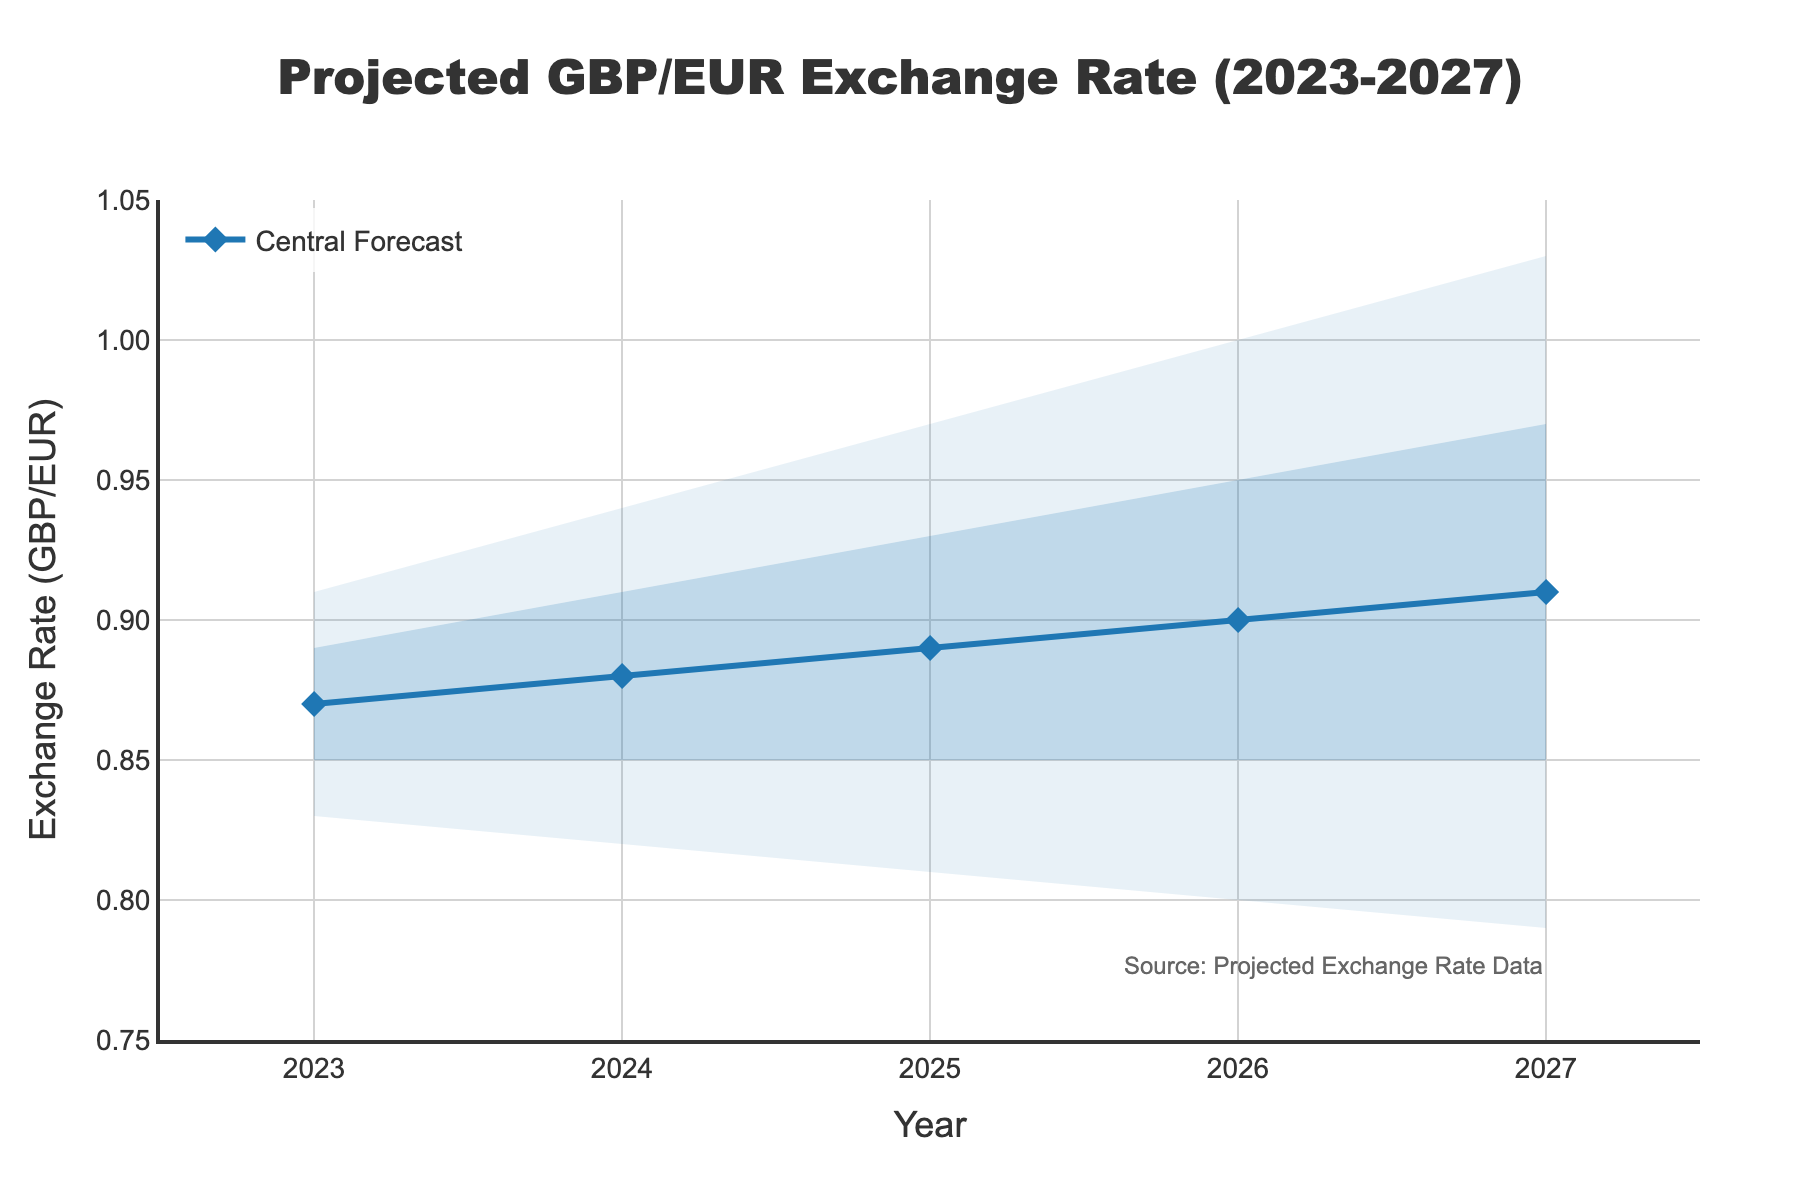What's the title of the figure? The title is usually displayed at the top of the figure. In this case, it reads "Projected GBP/EUR Exchange Rate (2023-2027)."
Answer: Projected GBP/EUR Exchange Rate (2023-2027) What does the central forecast indicate for 2025? The central forecast line represents the predicted average exchange rate each year. For 2025, it shows a value of 0.89.
Answer: 0.89 What is the range of the lower 10% and upper 10% projections for the year 2027? The lower 10% projection for 2027 is 0.79, and the upper 10% projection is 1.03.
Answer: 0.79 to 1.03 How does the central forecast trend over the years 2023 to 2027? By looking at the central forecast data points from 2023 to 2027, we can observe an upward trend from 0.87 in 2023 to 0.91 in 2027.
Answer: Upward What is the difference between the central forecast and the upper 10% projection for 2024? The central forecast for 2024 is 0.88, and the upper 10% projection is 0.94. The difference is 0.94 - 0.88 = 0.06.
Answer: 0.06 Which year has the narrowest range between the lower 30% and the upper 30% projections? To find this, we observe the respective values in the data and calculate the ranges. In 2023, the range is 0.89 - 0.85 = 0.04, 2024 = 0.91 - 0.85 = 0.06, 2025 = 0.93 - 0.85 = 0.08, 2026 = 0.95 - 0.85 = 0.10, 2027 = 0.97 - 0.85 = 0.12. 2023 has the narrowest range.
Answer: 2023 What is the projected lower bound (lower 10%) of the GBP/EUR exchange rate for 2026? The lower 10% projection for the year 2026 is 0.80.
Answer: 0.80 Between which years does the upper 30% projection cross the 1.0 mark? The upper 30% projection reaches 1.00 in 2026 and 1.03 in 2027. Therefore, it crosses the 1.0 mark between 2026 and 2027.
Answer: 2026 and 2027 In which year is the difference between the lower 10% and lower 30% projections the greatest? Calculating the differences: 2023: 0.85 - 0.83 = 0.02, 2024: 0.85 - 0.82 = 0.03, 2025: 0.85 - 0.81 = 0.04, 2026: 0.85 - 0.80 = 0.05, 2027: 0.85 - 0.79 = 0.06. The largest difference is in 2027.
Answer: 2027 